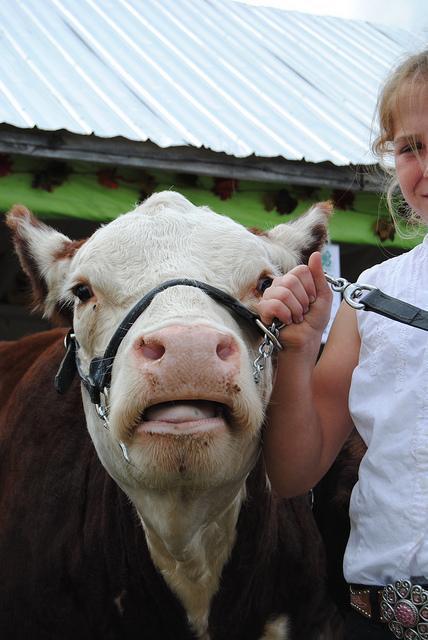How many cows can you see?
Give a very brief answer. 1. 